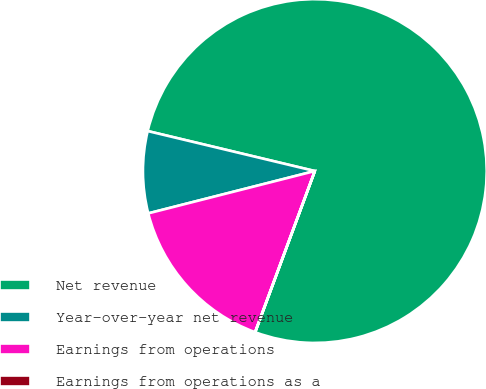<chart> <loc_0><loc_0><loc_500><loc_500><pie_chart><fcel>Net revenue<fcel>Year-over-year net revenue<fcel>Earnings from operations<fcel>Earnings from operations as a<nl><fcel>76.91%<fcel>7.7%<fcel>15.39%<fcel>0.01%<nl></chart> 